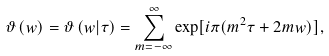<formula> <loc_0><loc_0><loc_500><loc_500>\vartheta \left ( w \right ) = \vartheta \left ( w | \tau \right ) = \sum _ { m = - \infty } ^ { \infty } \exp [ i \pi ( m ^ { 2 } \tau + 2 m w ) ] ,</formula> 